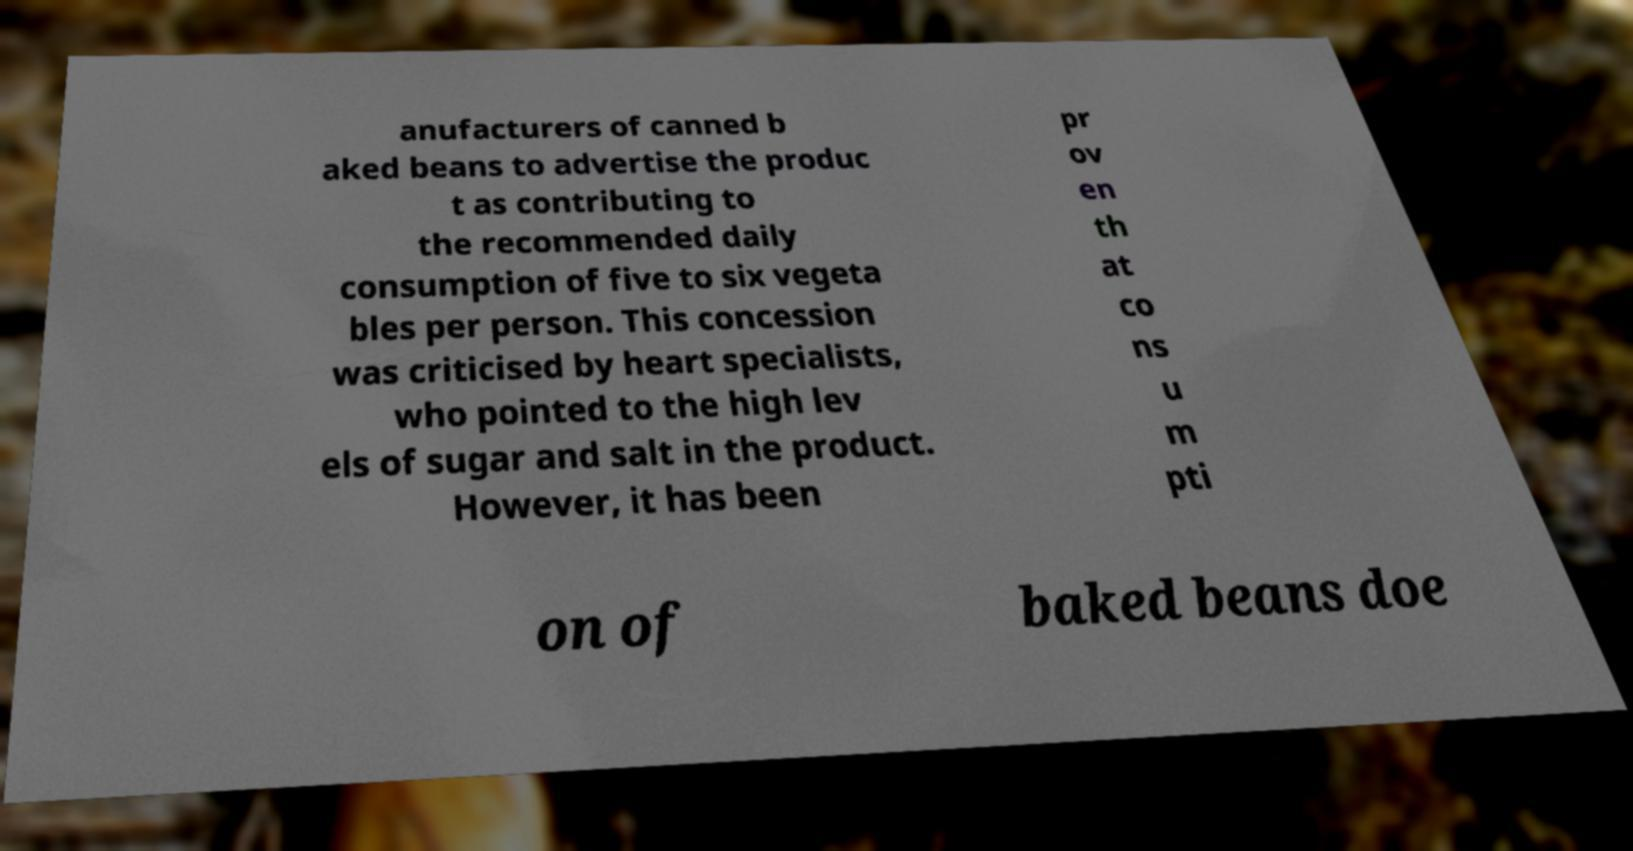Could you extract and type out the text from this image? anufacturers of canned b aked beans to advertise the produc t as contributing to the recommended daily consumption of five to six vegeta bles per person. This concession was criticised by heart specialists, who pointed to the high lev els of sugar and salt in the product. However, it has been pr ov en th at co ns u m pti on of baked beans doe 